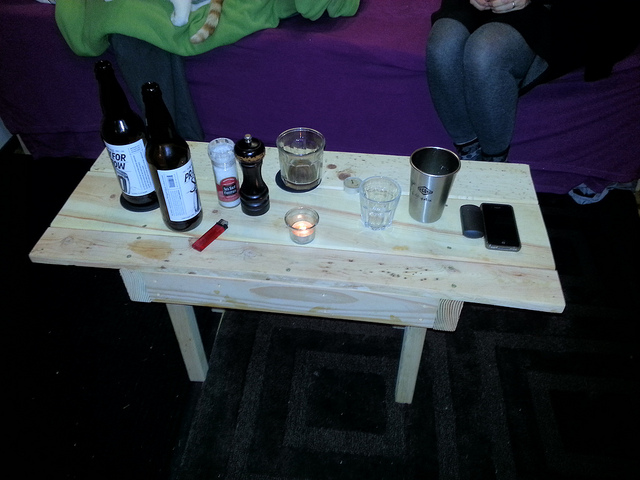What is the setting and possible occasion here based on the items on the table? The setting appears to be an informal gathering, perhaps a small party or social event. The presence of bottles and a candle suggests a relaxed and casual ambiance. 